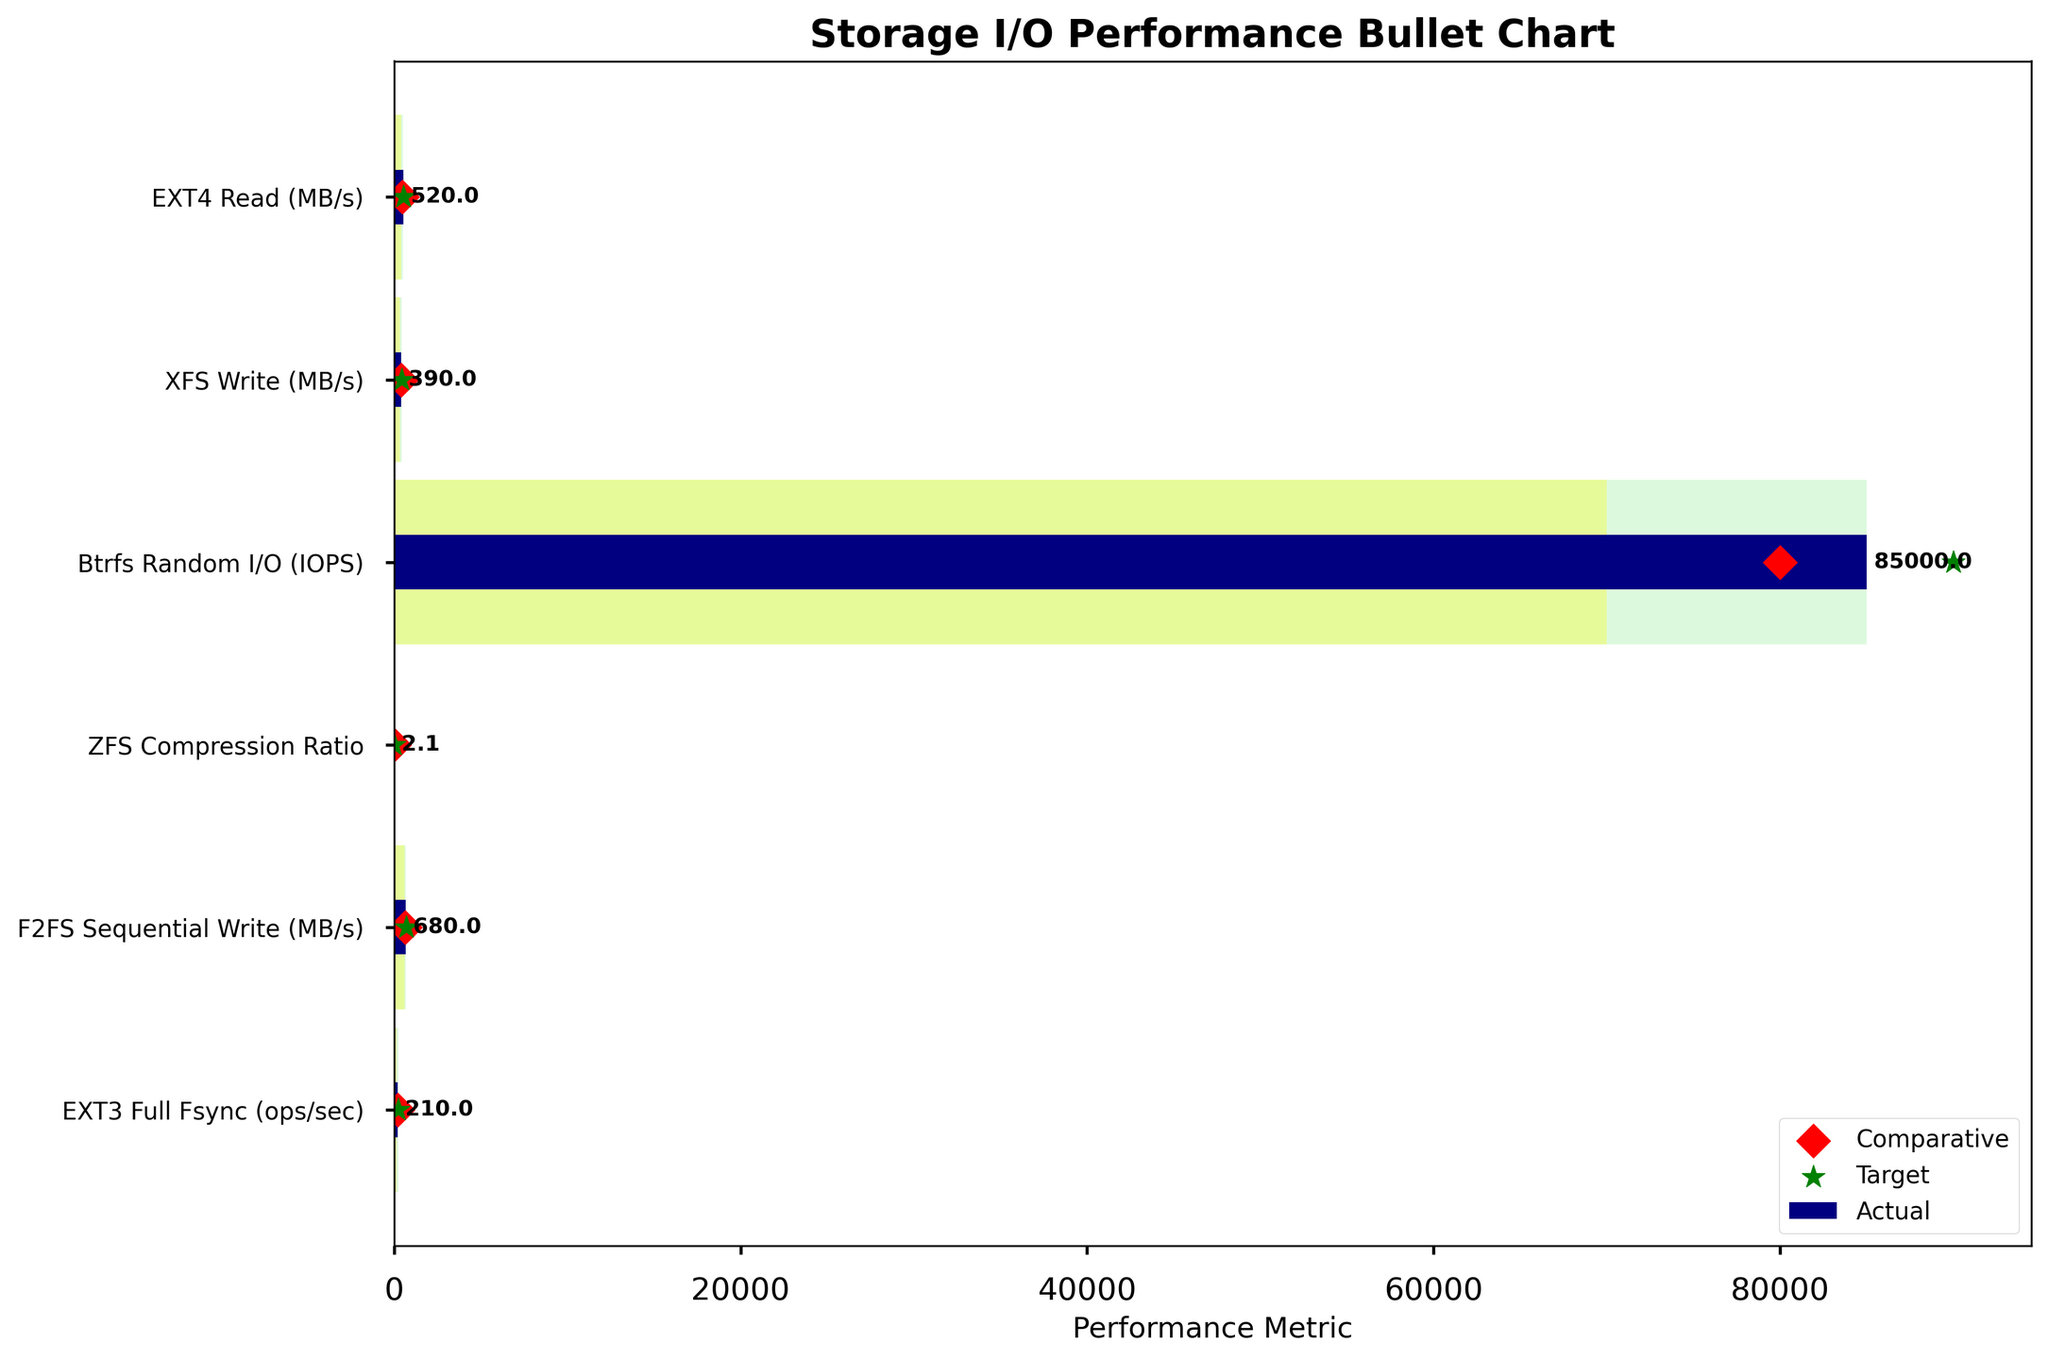What is the performance metric label on the x-axis? The label for the x-axis is clearly written at the bottom of the chart as "Performance Metric."
Answer: Performance Metric How many file systems are compared in this Bullet Chart? There are six horizontal bars, each representing a different file system, namely EXT4, XFS, Btrfs, ZFS, F2FS, and EXT3.
Answer: 6 Which file system has the highest Actual performance value? The highest Actual performance value among the file systems is examined, and F2FS Sequential Write has the highest Actual value of 680 MB/s.
Answer: F2FS What is the difference between the Actual and Comparative values for EXT4 Read? The Actual value for EXT4 Read is 520 MB/s, and the Comparative value is 480 MB/s. The difference is calculated as 520 - 480 = 40 MB/s.
Answer: 40 MB/s Which file system achieves its Target value in this chart? By looking closely, Btrfs Random I/O is the only file system whose Actual performance (85000 IOPS) meets its Target performance (90000 IOPS), as indicated by the bar touching the green zone representing the Target range.
Answer: Btrfs Compare the Actual performance of EXT3 Full Fsync with its Target and determine if it reaches it. The Actual performance of EXT3 Full Fsync is 210 ops/sec, and the Target performance is 250 ops/sec. A comparison shows that 210 is less than 250, indicating that it does not reach the Target.
Answer: No Which file system's Comparative value is higher than its Actual value? Checking each file system shows that XFS Write has a Comparative value (410 MB/s) higher than its Actual value (390 MB/s).
Answer: XFS How far is ZFS Compression Ratio from its Poor performance threshold? The ZFS Compression Ratio Actual value is 2.1, and its Poor performance threshold is 1. The difference is calculated as 2.1 - 1 = 1.1.
Answer: 1.1 What is the relationship between the Actual and Target performance values for F2FS Sequential Write? The Actual performance for F2FS Sequential Write is 680 MB/s, while the Target is 700 MB/s. Since 680 is less than 700, it indicates that the Actual performance is slightly below the Target.
Answer: Less Identify the file systems that fall under the Satisfactory range for their Performance Metric. The Satisfactory range is represented in yellow. Upon reviewing each bar, both XFS Write and F2FS Sequential Write fall within this range for their respective metrics.
Answer: XFS, F2FS 